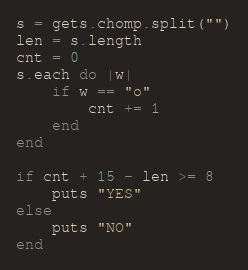Convert code to text. <code><loc_0><loc_0><loc_500><loc_500><_Ruby_>s = gets.chomp.split("")
len = s.length
cnt = 0
s.each do |w|
    if w == "o"
        cnt += 1
    end
end

if cnt + 15 - len >= 8
    puts "YES"
else
    puts "NO"
end</code> 